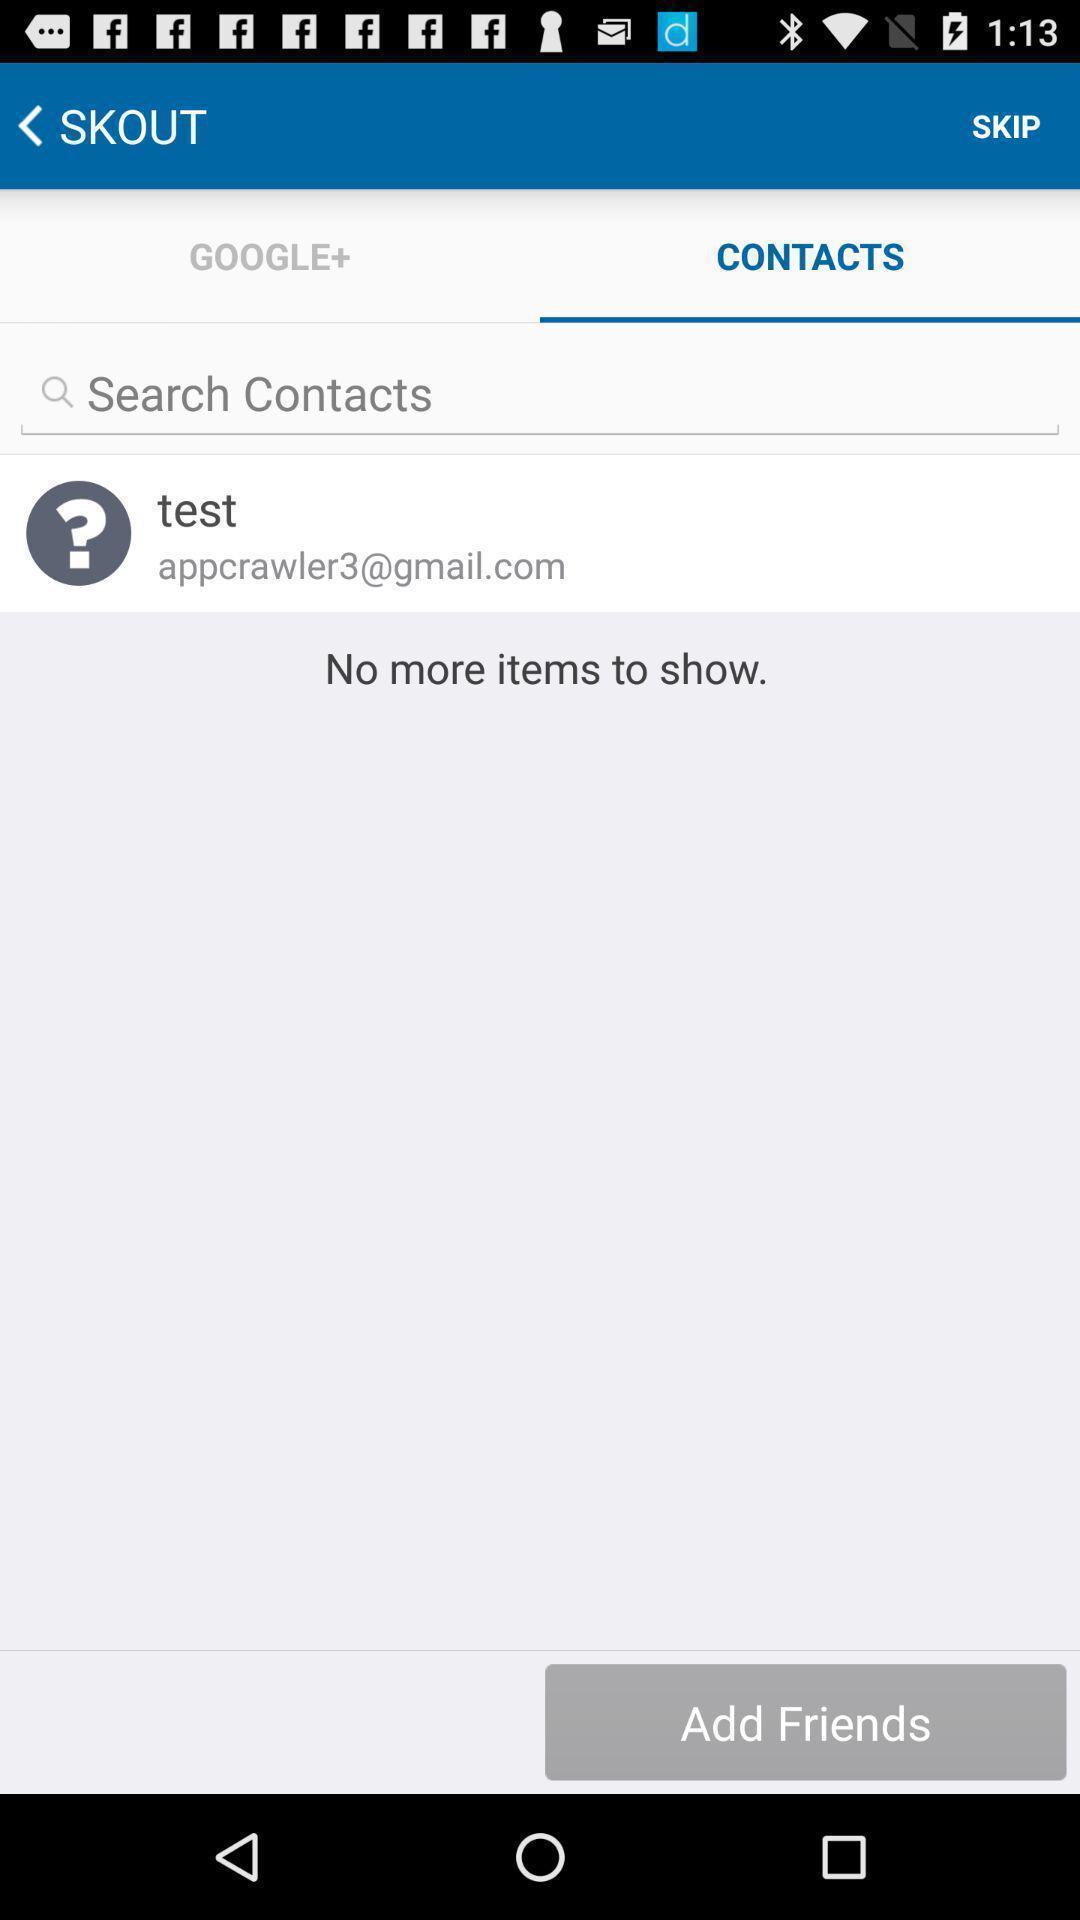Provide a textual representation of this image. Search page of contacts app. 